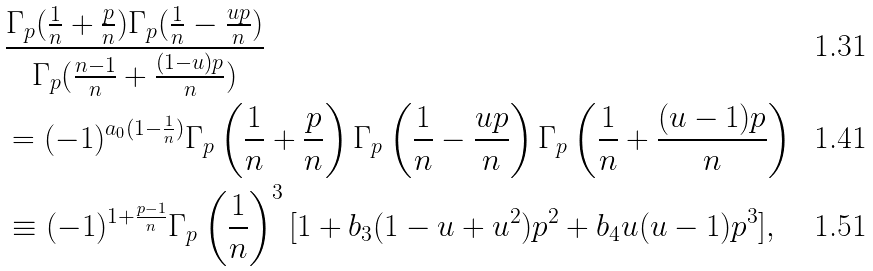Convert formula to latex. <formula><loc_0><loc_0><loc_500><loc_500>& \frac { \Gamma _ { p } ( \frac { 1 } { n } + \frac { p } { n } ) \Gamma _ { p } ( \frac { 1 } { n } - \frac { u p } { n } ) } { \Gamma _ { p } ( \frac { n - 1 } { n } + \frac { ( 1 - u ) p } { n } ) } \\ & = ( - 1 ) ^ { a _ { 0 } ( 1 - \frac { 1 } { n } ) } \Gamma _ { p } \left ( \frac { 1 } { n } + \frac { p } { n } \right ) \Gamma _ { p } \left ( \frac { 1 } { n } - \frac { u p } { n } \right ) \Gamma _ { p } \left ( \frac { 1 } { n } + \frac { ( u - 1 ) p } { n } \right ) \\ & \equiv ( - 1 ) ^ { 1 + \frac { p - 1 } { n } } \Gamma _ { p } \left ( \frac { 1 } { n } \right ) ^ { 3 } [ 1 + b _ { 3 } ( 1 - u + u ^ { 2 } ) p ^ { 2 } + b _ { 4 } u ( u - 1 ) p ^ { 3 } ] ,</formula> 